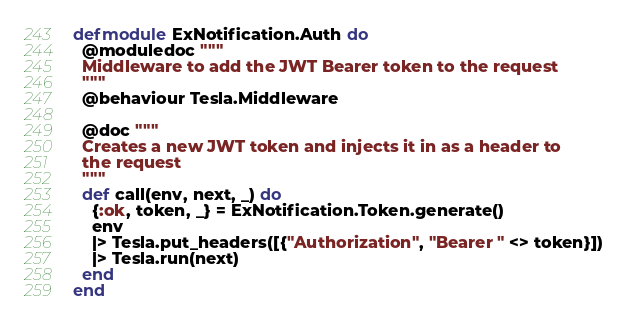Convert code to text. <code><loc_0><loc_0><loc_500><loc_500><_Elixir_>defmodule ExNotification.Auth do
  @moduledoc """
  Middleware to add the JWT Bearer token to the request
  """
  @behaviour Tesla.Middleware

  @doc """
  Creates a new JWT token and injects it in as a header to
  the request
  """
  def call(env, next, _) do
    {:ok, token, _} = ExNotification.Token.generate()
    env
    |> Tesla.put_headers([{"Authorization", "Bearer " <> token}])
    |> Tesla.run(next)
  end
end
</code> 